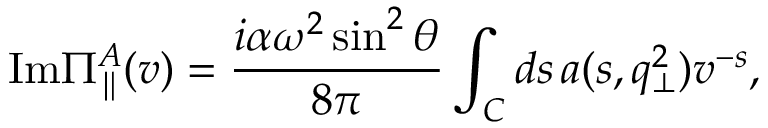Convert formula to latex. <formula><loc_0><loc_0><loc_500><loc_500>I m \Pi _ { \| } ^ { A } ( v ) = \frac { i \alpha \omega ^ { 2 } \sin ^ { 2 } \theta } { 8 \pi } \int _ { C } d s \, a ( s , q _ { \bot } ^ { 2 } ) v ^ { - s } ,</formula> 